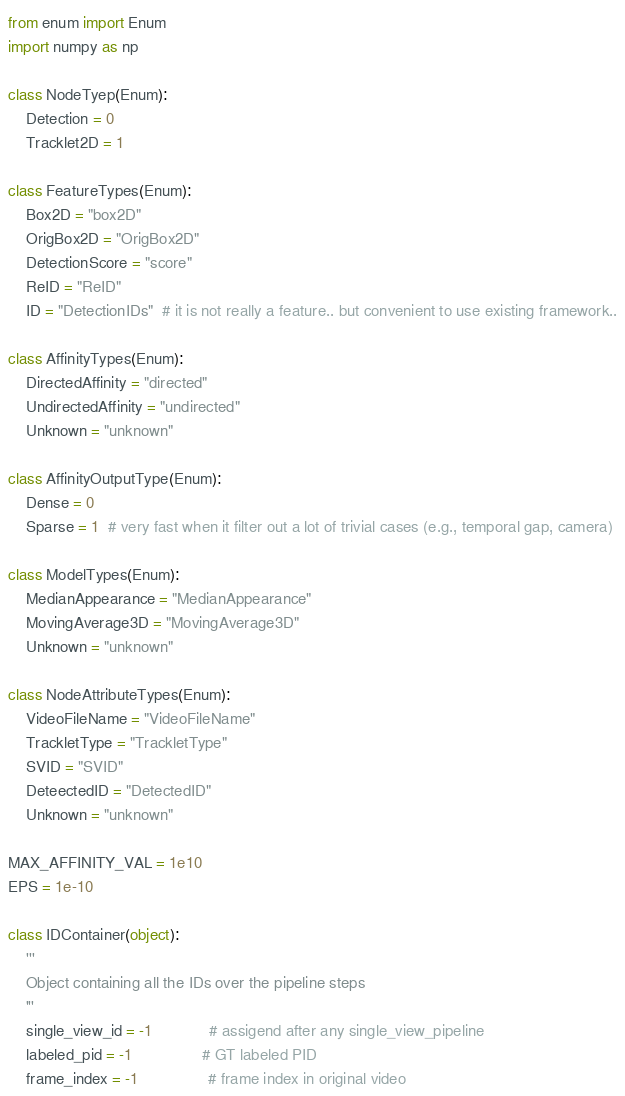Convert code to text. <code><loc_0><loc_0><loc_500><loc_500><_Python_>from enum import Enum
import numpy as np

class NodeTyep(Enum):
    Detection = 0
    Tracklet2D = 1

class FeatureTypes(Enum):
    Box2D = "box2D"
    OrigBox2D = "OrigBox2D"
    DetectionScore = "score"
    ReID = "ReID"
    ID = "DetectionIDs"  # it is not really a feature.. but convenient to use existing framework..

class AffinityTypes(Enum):
    DirectedAffinity = "directed"
    UndirectedAffinity = "undirected"
    Unknown = "unknown"

class AffinityOutputType(Enum):
    Dense = 0
    Sparse = 1  # very fast when it filter out a lot of trivial cases (e.g., temporal gap, camera)

class ModelTypes(Enum):
    MedianAppearance = "MedianAppearance"
    MovingAverage3D = "MovingAverage3D"
    Unknown = "unknown"

class NodeAttributeTypes(Enum):
    VideoFileName = "VideoFileName"
    TrackletType = "TrackletType"
    SVID = "SVID"
    DeteectedID = "DetectedID"
    Unknown = "unknown"

MAX_AFFINITY_VAL = 1e10
EPS = 1e-10

class IDContainer(object):
    '''
    Object containing all the IDs over the pipeline steps
    '''
    single_view_id = -1             # assigend after any single_view_pipeline
    labeled_pid = -1                # GT labeled PID
    frame_index = -1                # frame index in original video
</code> 